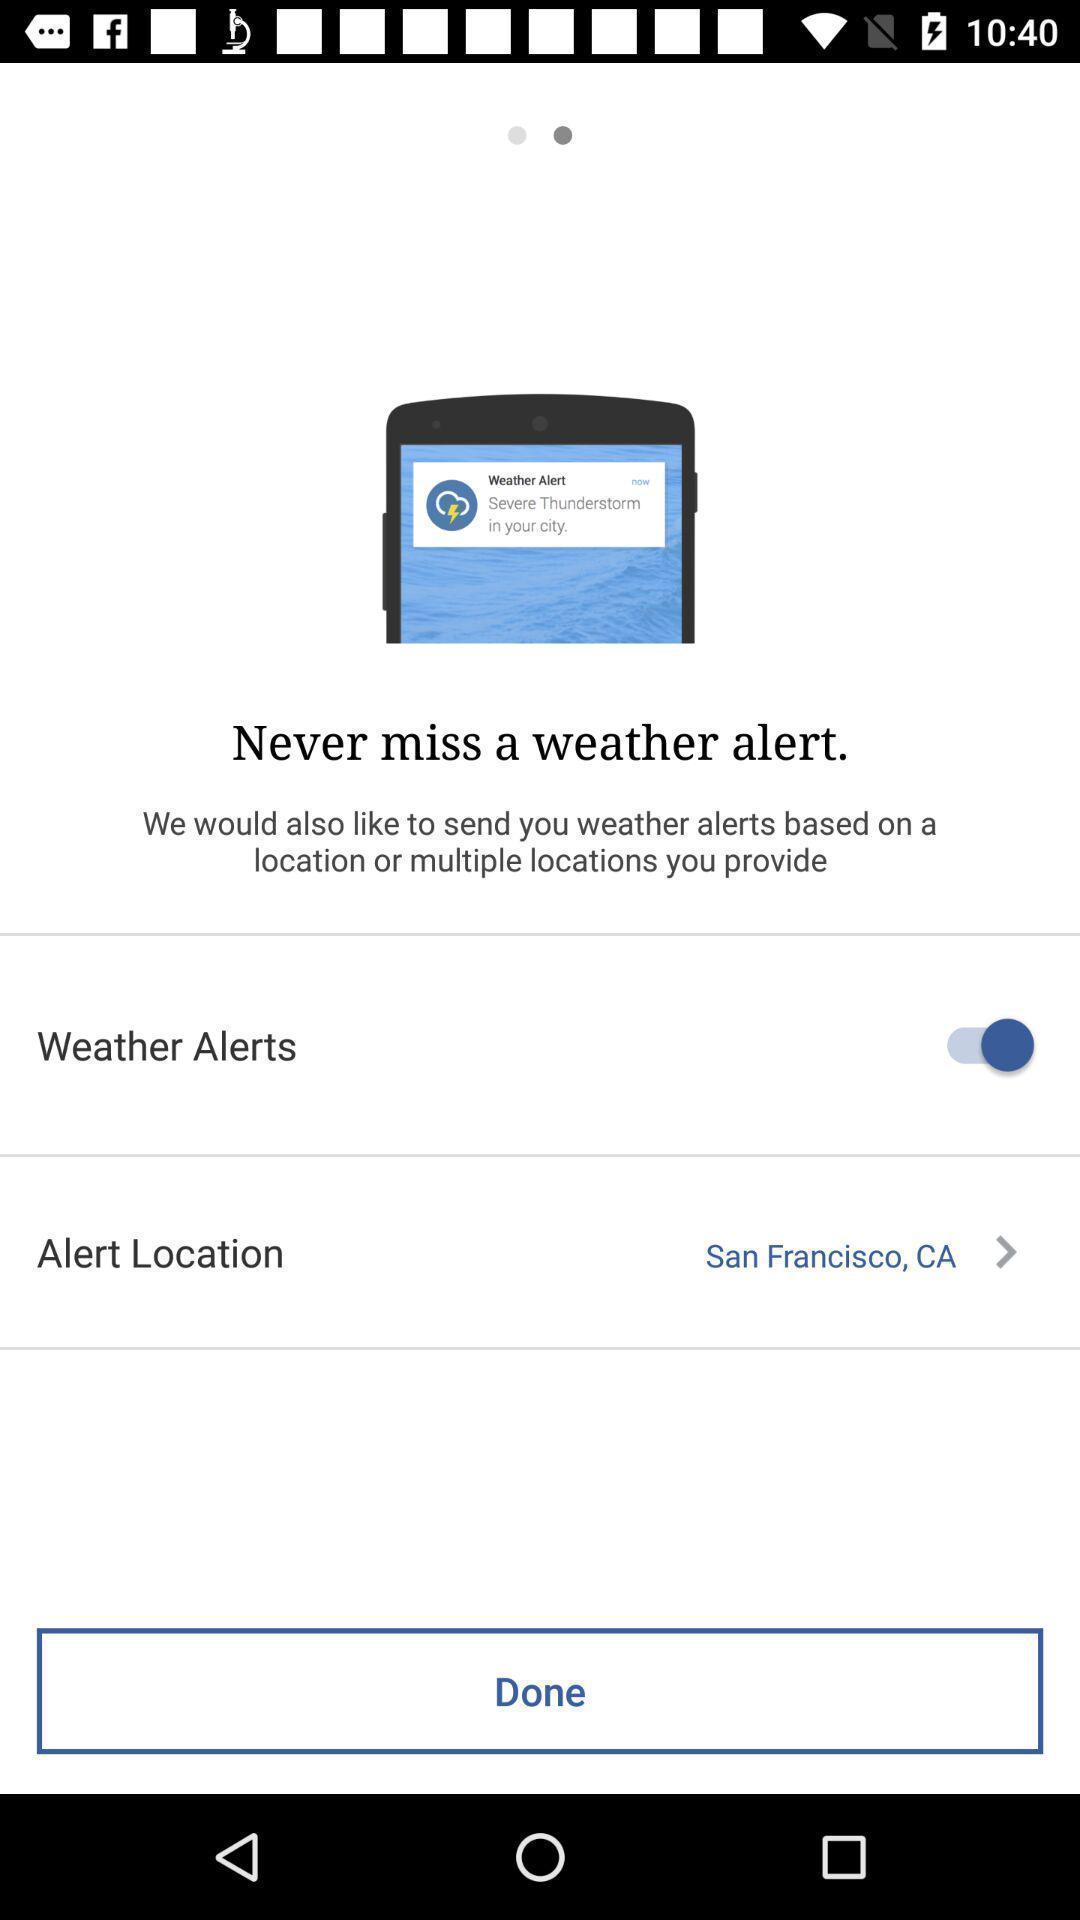Describe the content in this image. Screen displaying multiple alert options in a weather application. 